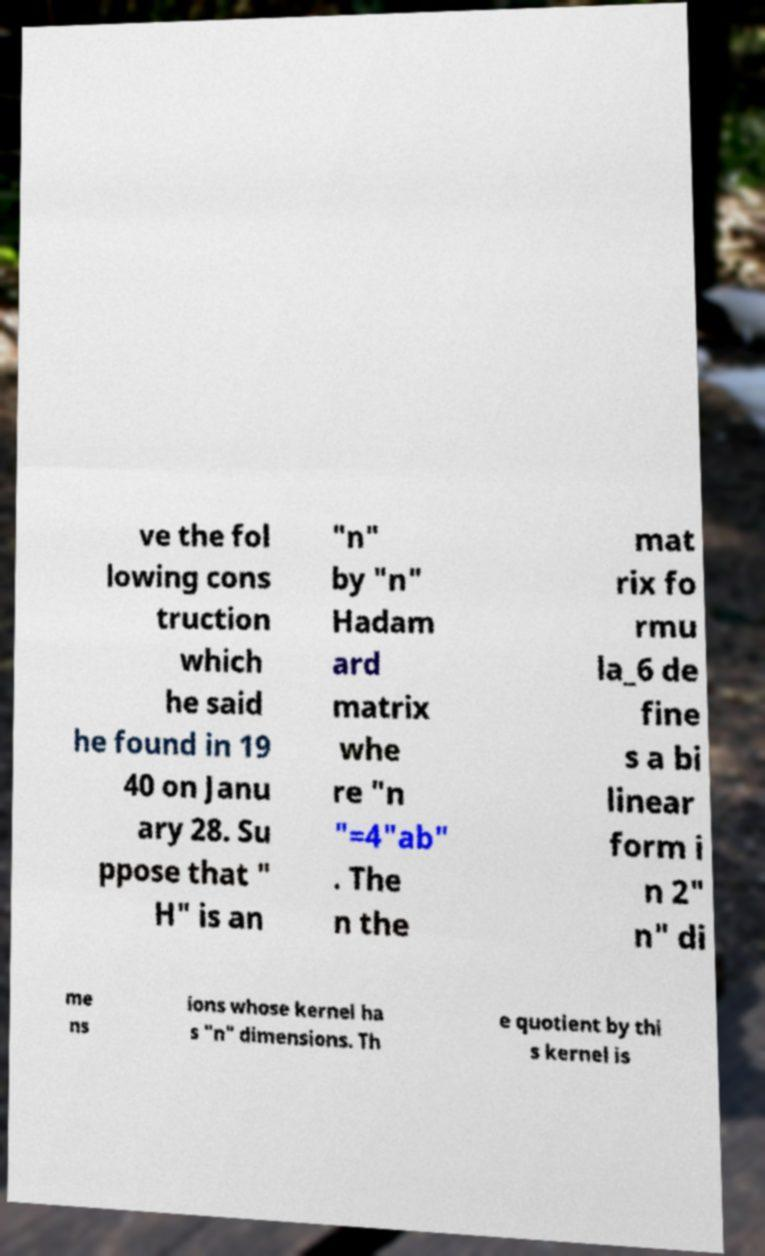Please identify and transcribe the text found in this image. ve the fol lowing cons truction which he said he found in 19 40 on Janu ary 28. Su ppose that " H" is an "n" by "n" Hadam ard matrix whe re "n "=4"ab" . The n the mat rix fo rmu la_6 de fine s a bi linear form i n 2" n" di me ns ions whose kernel ha s "n" dimensions. Th e quotient by thi s kernel is 